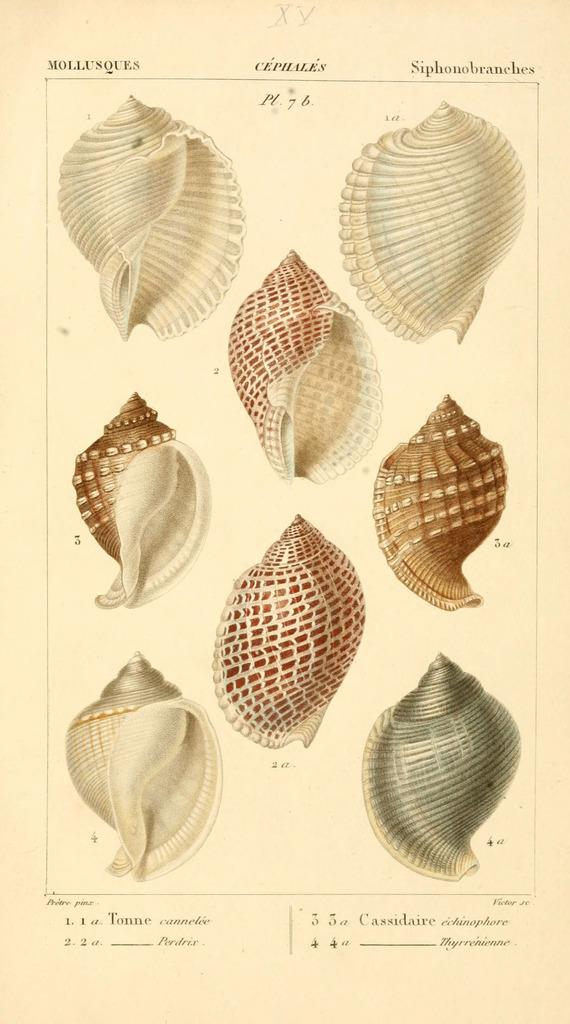What type of objects can be seen in the image? There are seashells in the image. Is there any text present in the image? Yes, there is some text in the image. How many horses can be seen grazing in the image? There are no horses present in the image. What type of berry is visible in the image? There is no berry visible in the image. 